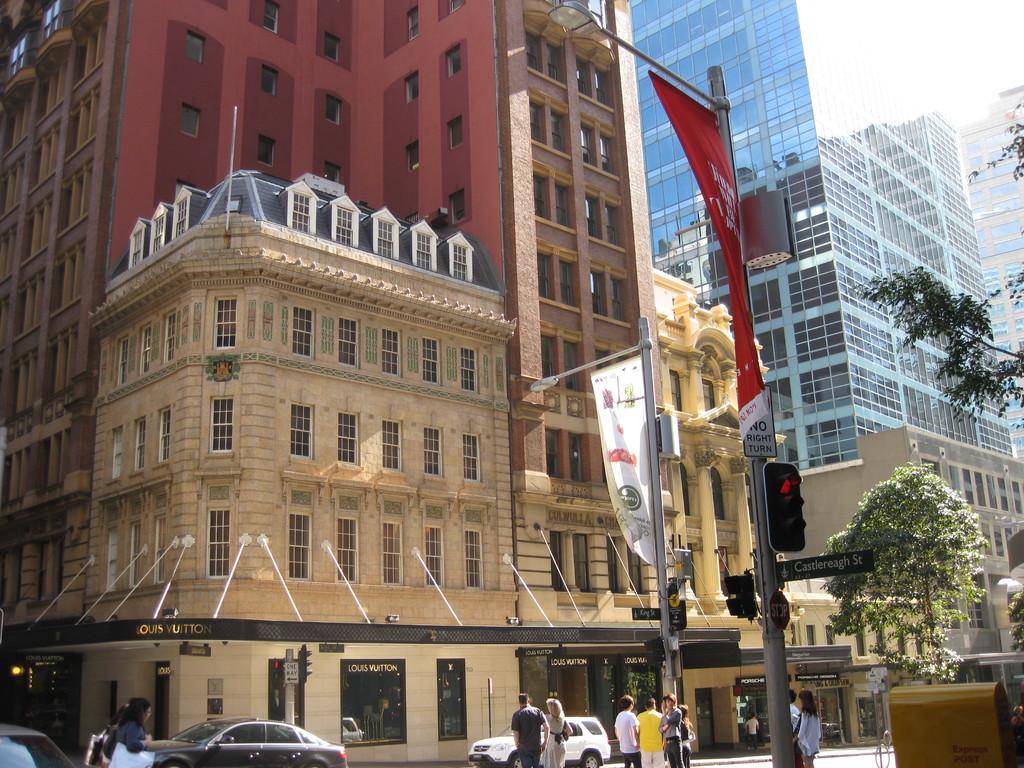Could you give a brief overview of what you see in this image? In this picture we can see people, vehicles on the ground, here we can see traffic signals, electric poles with lights, banners, trees and some objects and in the background we can see buildings. 